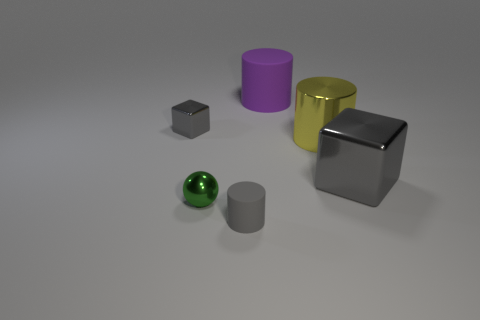How does the lighting in the image affect the appearance of the objects? The lighting creates soft shadows and highlights which give the objects a three-dimensional appearance and help distinguish their textures and materials. The reflections on the metallic surfaces, such as the silver cube, are more pronounced than on the matte surfaces, accentuating their different properties. 